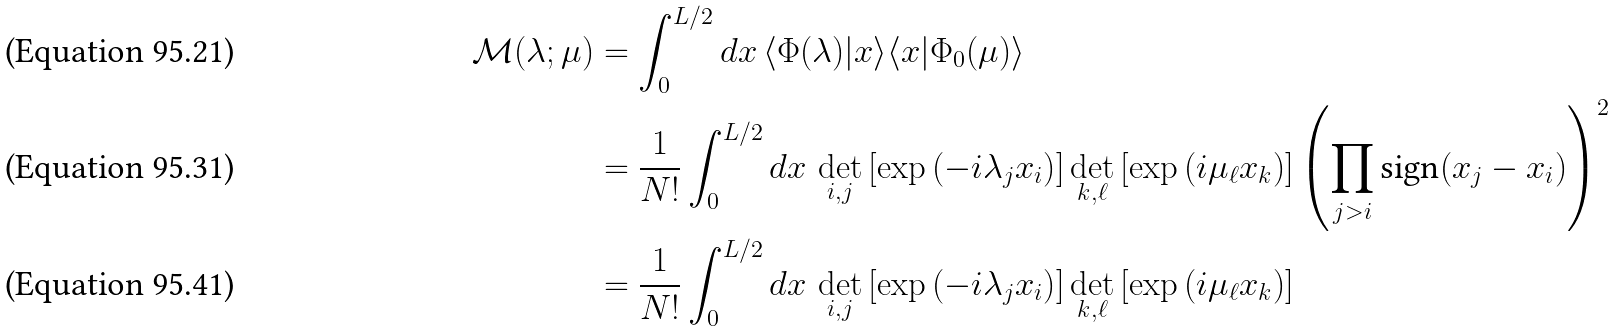Convert formula to latex. <formula><loc_0><loc_0><loc_500><loc_500>\mathcal { M } ( \lambda ; \mu ) & = \int _ { 0 } ^ { L / 2 } d x \, \langle \Phi ( \lambda ) | x \rangle \langle x | \Phi _ { 0 } ( \mu ) \rangle \\ & = \frac { 1 } { N ! } \int _ { 0 } ^ { L / 2 } d x \, \det _ { i , j } \left [ \exp \left ( - i \lambda _ { j } x _ { i } \right ) \right ] \det _ { k , \ell } \left [ \exp \left ( i \mu _ { \ell } x _ { k } \right ) \right ] \left ( \prod _ { j > i } \text {sign} ( x _ { j } - x _ { i } ) \right ) ^ { 2 } \\ & = \frac { 1 } { N ! } \int _ { 0 } ^ { L / 2 } d x \, \det _ { i , j } \left [ \exp \left ( - i \lambda _ { j } x _ { i } \right ) \right ] \det _ { k , \ell } \left [ \exp \left ( i \mu _ { \ell } x _ { k } \right ) \right ]</formula> 